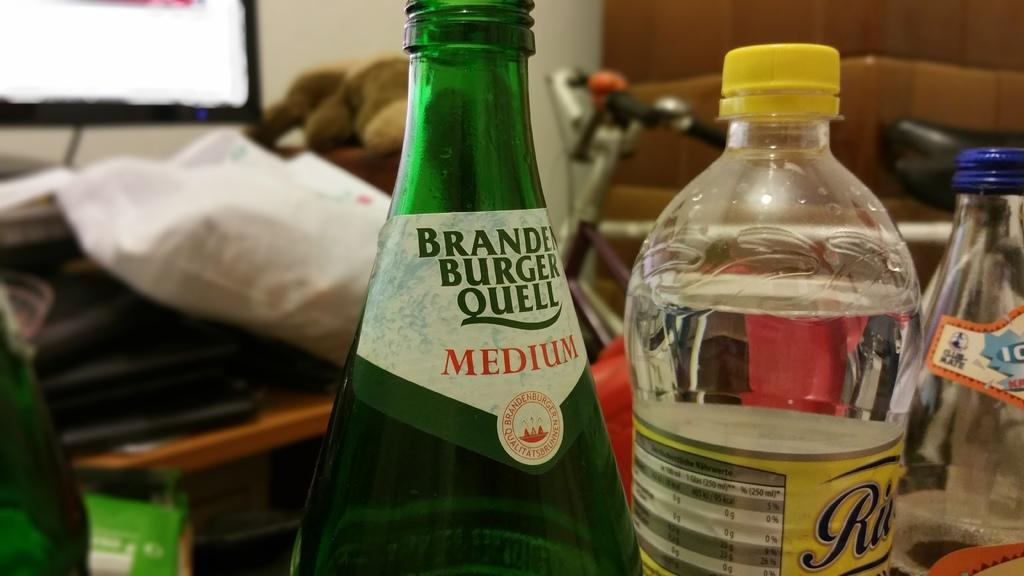Describe this image in one or two sentences. In this image I can see few bottles. In the background I can see a cycle and a screen. 